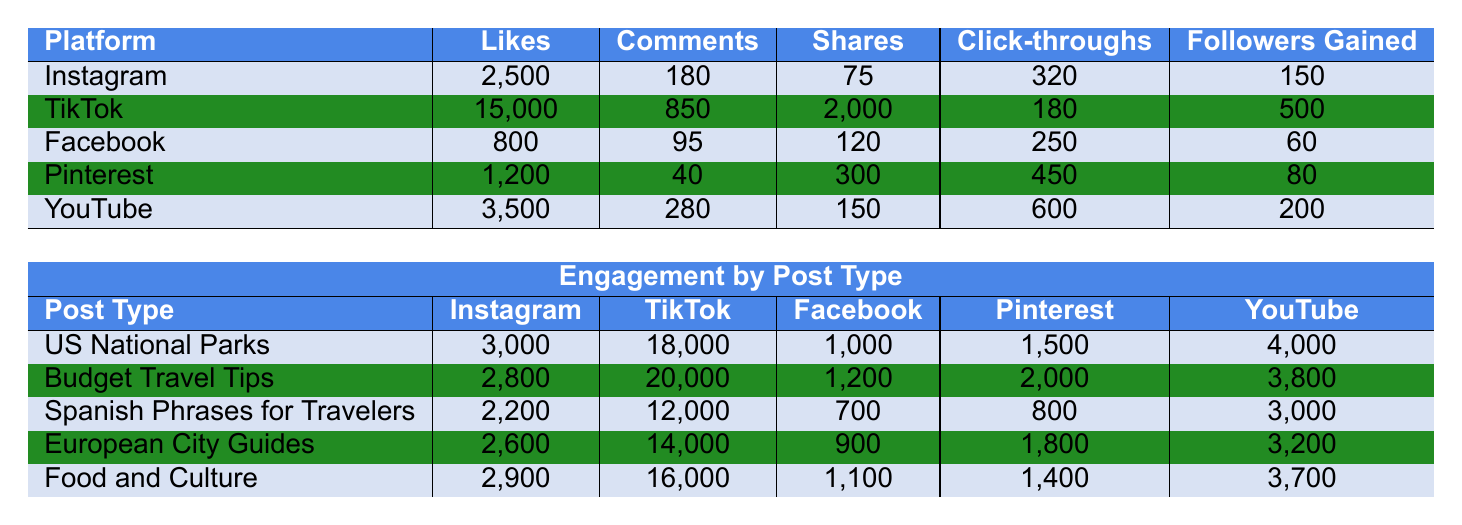What social media platform has the highest number of likes? By looking at the Likes column, TikTok has 15,000 likes, which is higher than the other platforms.
Answer: TikTok Which platform has the lowest number of comments? The Comments column shows that Pinterest has 40 comments, which is the lowest among all platforms.
Answer: Pinterest What is the total number of shares across all platforms? Adding the shares: 75 (Instagram) + 2000 (TikTok) + 120 (Facebook) + 300 (Pinterest) + 150 (YouTube) = 2645.
Answer: 2645 Which post type received the most likes on Instagram? Checking the Likes for each post type on Instagram, "Budget Travel Tips" received 2800 likes, the highest in that category.
Answer: Budget Travel Tips Did TikTok receive more click-throughs than YouTube? For TikTok, there are 180 click-throughs, and for YouTube, there are 600 click-throughs. Since 180 is less than 600, the statement is false.
Answer: No What is the average number of followers gained across all platforms? Adding all the Followers Gained: 150 (Instagram) + 500 (TikTok) + 60 (Facebook) + 80 (Pinterest) + 200 (YouTube) = 990. Dividing by 5 (the number of platforms), the average is 990 / 5 = 198.
Answer: 198 Which post type has the highest engagement on TikTok? Looking at TikTok's engagement, "Budget Travel Tips" has 20,000 engagements, which is more than any other post type listed.
Answer: Budget Travel Tips Is the number of likes on YouTube greater than the number of shares on Facebook? YouTube has 3,500 likes and Facebook has 120 shares. 3,500 is greater than 120, so the statement is true.
Answer: Yes What is the difference in the number of followers gained between TikTok and Facebook? TikTok gained 500 followers, while Facebook gained 60. The difference is 500 - 60 = 440.
Answer: 440 Among all post types, which had the lowest total engagement across all platforms? Summing engagement for each post type: US National Parks (3000 + 18000 + 1000 + 1500 + 4000 = 27,500), Budget Travel Tips (2800 + 20000 + 1200 + 2000 + 3800 = 29,800), Spanish Phrases (2200 + 12000 + 700 + 800 + 3000 = 18,700), European City Guides (2600 + 14000 + 900 + 1800 + 3200 = 17,500), Food and Culture (2900 + 16000 + 1100 + 1400 + 3700 = 20,100). European City Guides has the lowest total engagement at 17,500.
Answer: European City Guides 